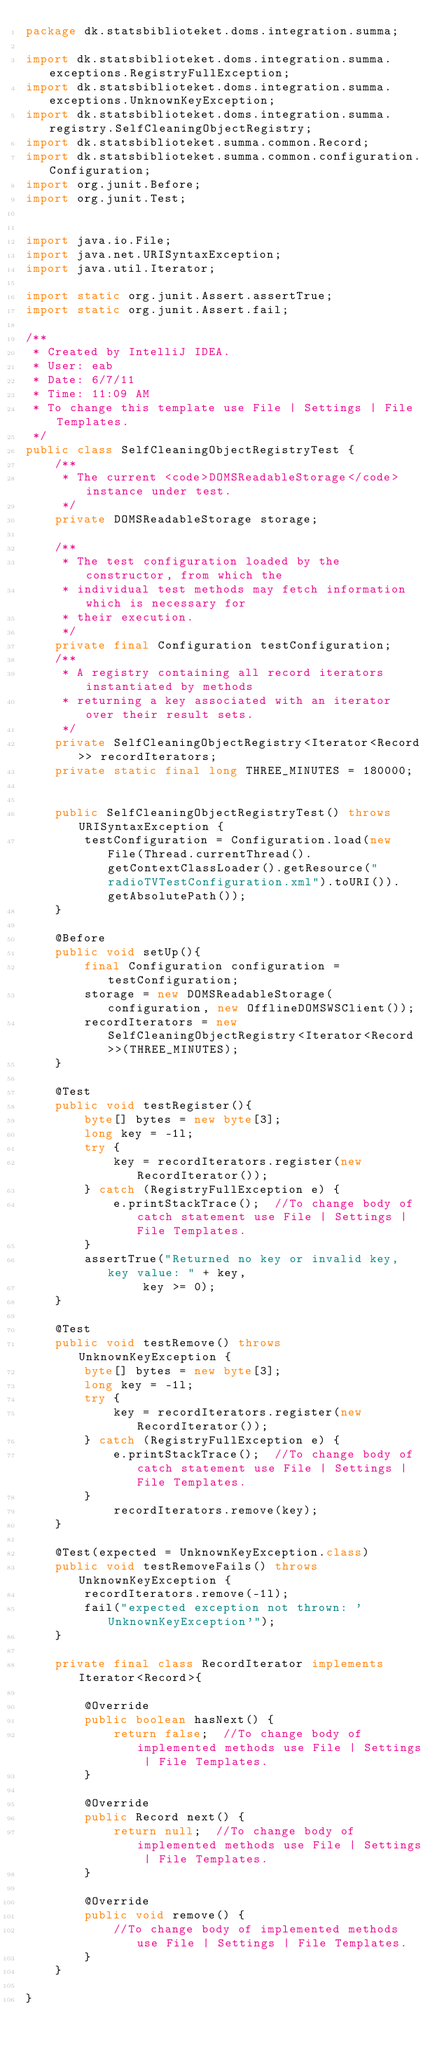<code> <loc_0><loc_0><loc_500><loc_500><_Java_>package dk.statsbiblioteket.doms.integration.summa;

import dk.statsbiblioteket.doms.integration.summa.exceptions.RegistryFullException;
import dk.statsbiblioteket.doms.integration.summa.exceptions.UnknownKeyException;
import dk.statsbiblioteket.doms.integration.summa.registry.SelfCleaningObjectRegistry;
import dk.statsbiblioteket.summa.common.Record;
import dk.statsbiblioteket.summa.common.configuration.Configuration;
import org.junit.Before;
import org.junit.Test;


import java.io.File;
import java.net.URISyntaxException;
import java.util.Iterator;

import static org.junit.Assert.assertTrue;
import static org.junit.Assert.fail;

/**
 * Created by IntelliJ IDEA.
 * User: eab
 * Date: 6/7/11
 * Time: 11:09 AM
 * To change this template use File | Settings | File Templates.
 */
public class SelfCleaningObjectRegistryTest {
    /**
     * The current <code>DOMSReadableStorage</code> instance under test.
     */
    private DOMSReadableStorage storage;

    /**
     * The test configuration loaded by the constructor, from which the
     * individual test methods may fetch information which is necessary for
     * their execution.
     */
    private final Configuration testConfiguration;
    /**
     * A registry containing all record iterators instantiated by methods
     * returning a key associated with an iterator over their result sets.
     */
    private SelfCleaningObjectRegistry<Iterator<Record>> recordIterators;
    private static final long THREE_MINUTES = 180000;


    public SelfCleaningObjectRegistryTest() throws URISyntaxException {
        testConfiguration = Configuration.load(new File(Thread.currentThread().getContextClassLoader().getResource("radioTVTestConfiguration.xml").toURI()).getAbsolutePath());
    }

    @Before
    public void setUp(){
        final Configuration configuration = testConfiguration;
        storage = new DOMSReadableStorage(configuration, new OfflineDOMSWSClient());
        recordIterators = new SelfCleaningObjectRegistry<Iterator<Record>>(THREE_MINUTES);
    }

    @Test
    public void testRegister(){
        byte[] bytes = new byte[3];
        long key = -1l;
        try {
            key = recordIterators.register(new RecordIterator());
        } catch (RegistryFullException e) {
            e.printStackTrace();  //To change body of catch statement use File | Settings | File Templates.
        }
        assertTrue("Returned no key or invalid key, key value: " + key,
                key >= 0);
    }

    @Test
    public void testRemove() throws UnknownKeyException {
        byte[] bytes = new byte[3];
        long key = -1l;
        try {
            key = recordIterators.register(new RecordIterator());
        } catch (RegistryFullException e) {
            e.printStackTrace();  //To change body of catch statement use File | Settings | File Templates.
        }
            recordIterators.remove(key);
    }

    @Test(expected = UnknownKeyException.class)
    public void testRemoveFails() throws UnknownKeyException {
        recordIterators.remove(-1l);
        fail("expected exception not thrown: 'UnknownKeyException'");
    }

    private final class RecordIterator implements Iterator<Record>{

        @Override
        public boolean hasNext() {
            return false;  //To change body of implemented methods use File | Settings | File Templates.
        }

        @Override
        public Record next() {
            return null;  //To change body of implemented methods use File | Settings | File Templates.
        }

        @Override
        public void remove() {
            //To change body of implemented methods use File | Settings | File Templates.
        }
    }

}
</code> 